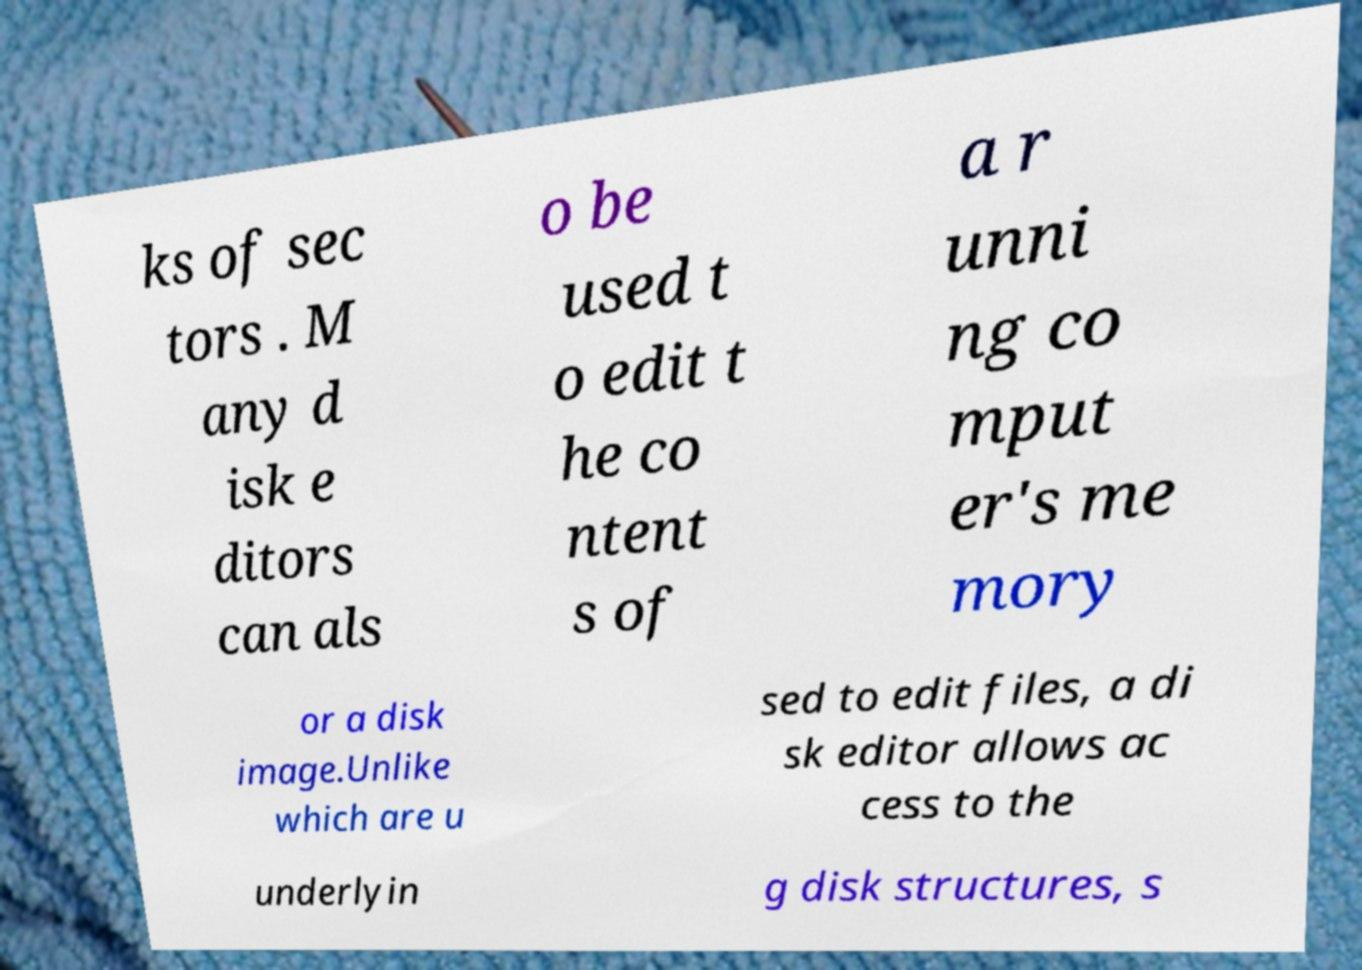What messages or text are displayed in this image? I need them in a readable, typed format. ks of sec tors . M any d isk e ditors can als o be used t o edit t he co ntent s of a r unni ng co mput er's me mory or a disk image.Unlike which are u sed to edit files, a di sk editor allows ac cess to the underlyin g disk structures, s 